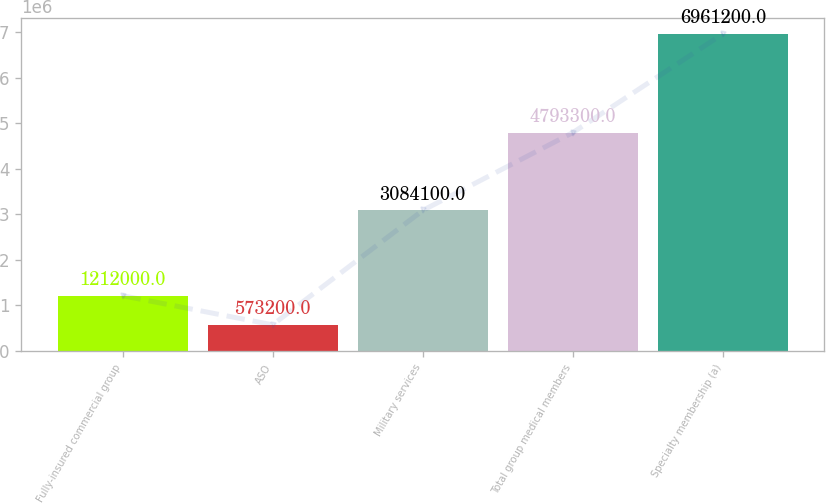<chart> <loc_0><loc_0><loc_500><loc_500><bar_chart><fcel>Fully-insured commercial group<fcel>ASO<fcel>Military services<fcel>Total group medical members<fcel>Specialty membership (a)<nl><fcel>1.212e+06<fcel>573200<fcel>3.0841e+06<fcel>4.7933e+06<fcel>6.9612e+06<nl></chart> 